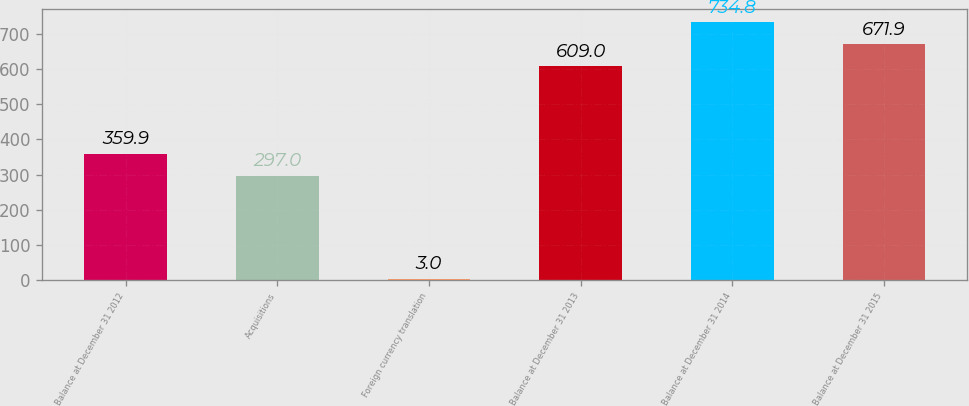<chart> <loc_0><loc_0><loc_500><loc_500><bar_chart><fcel>Balance at December 31 2012<fcel>Acquisitions<fcel>Foreign currency translation<fcel>Balance at December 31 2013<fcel>Balance at December 31 2014<fcel>Balance at December 31 2015<nl><fcel>359.9<fcel>297<fcel>3<fcel>609<fcel>734.8<fcel>671.9<nl></chart> 